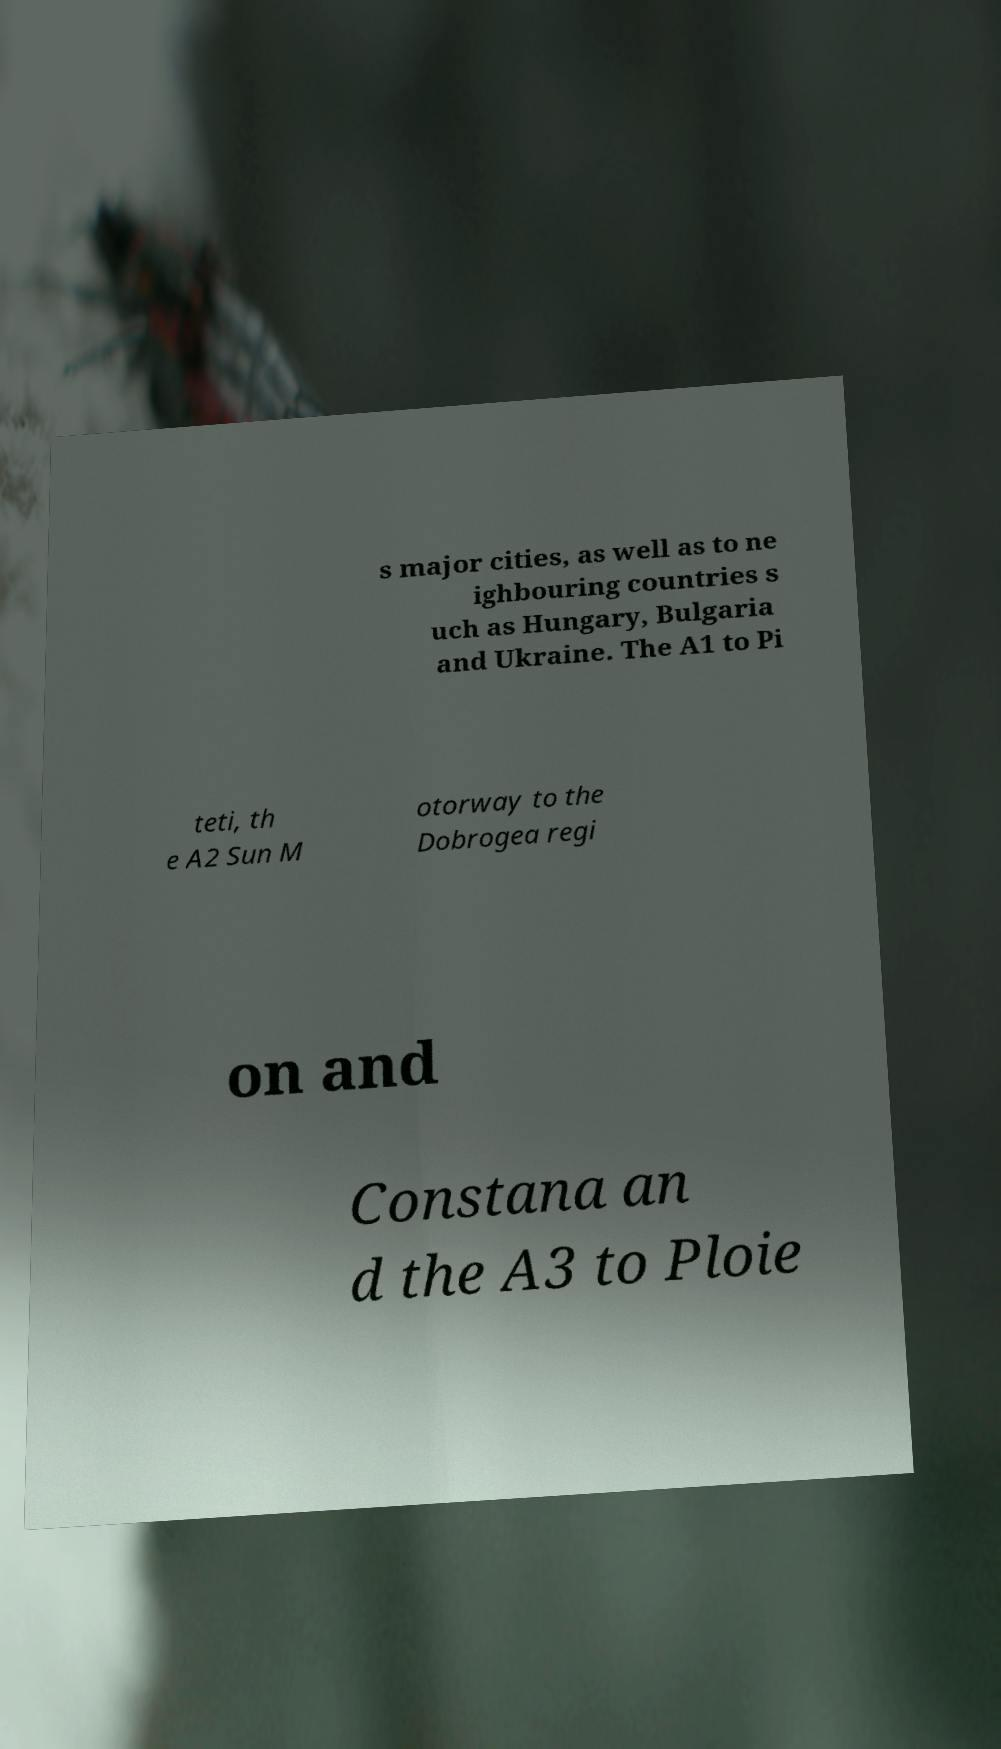There's text embedded in this image that I need extracted. Can you transcribe it verbatim? s major cities, as well as to ne ighbouring countries s uch as Hungary, Bulgaria and Ukraine. The A1 to Pi teti, th e A2 Sun M otorway to the Dobrogea regi on and Constana an d the A3 to Ploie 